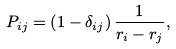Convert formula to latex. <formula><loc_0><loc_0><loc_500><loc_500>P _ { i j } = \left ( 1 - \delta _ { i j } \right ) \frac { 1 } { r _ { i } - r _ { j } } ,</formula> 